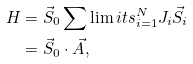Convert formula to latex. <formula><loc_0><loc_0><loc_500><loc_500>H & = \vec { S } _ { 0 } \sum \lim i t s _ { i = 1 } ^ { N } J _ { i } \vec { S } _ { i } \\ & = \vec { S } _ { 0 } \cdot \vec { A } ,</formula> 